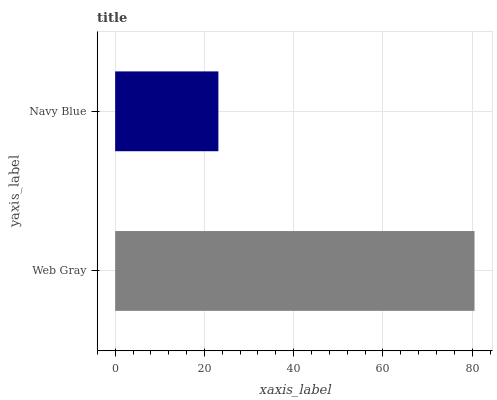Is Navy Blue the minimum?
Answer yes or no. Yes. Is Web Gray the maximum?
Answer yes or no. Yes. Is Navy Blue the maximum?
Answer yes or no. No. Is Web Gray greater than Navy Blue?
Answer yes or no. Yes. Is Navy Blue less than Web Gray?
Answer yes or no. Yes. Is Navy Blue greater than Web Gray?
Answer yes or no. No. Is Web Gray less than Navy Blue?
Answer yes or no. No. Is Web Gray the high median?
Answer yes or no. Yes. Is Navy Blue the low median?
Answer yes or no. Yes. Is Navy Blue the high median?
Answer yes or no. No. Is Web Gray the low median?
Answer yes or no. No. 